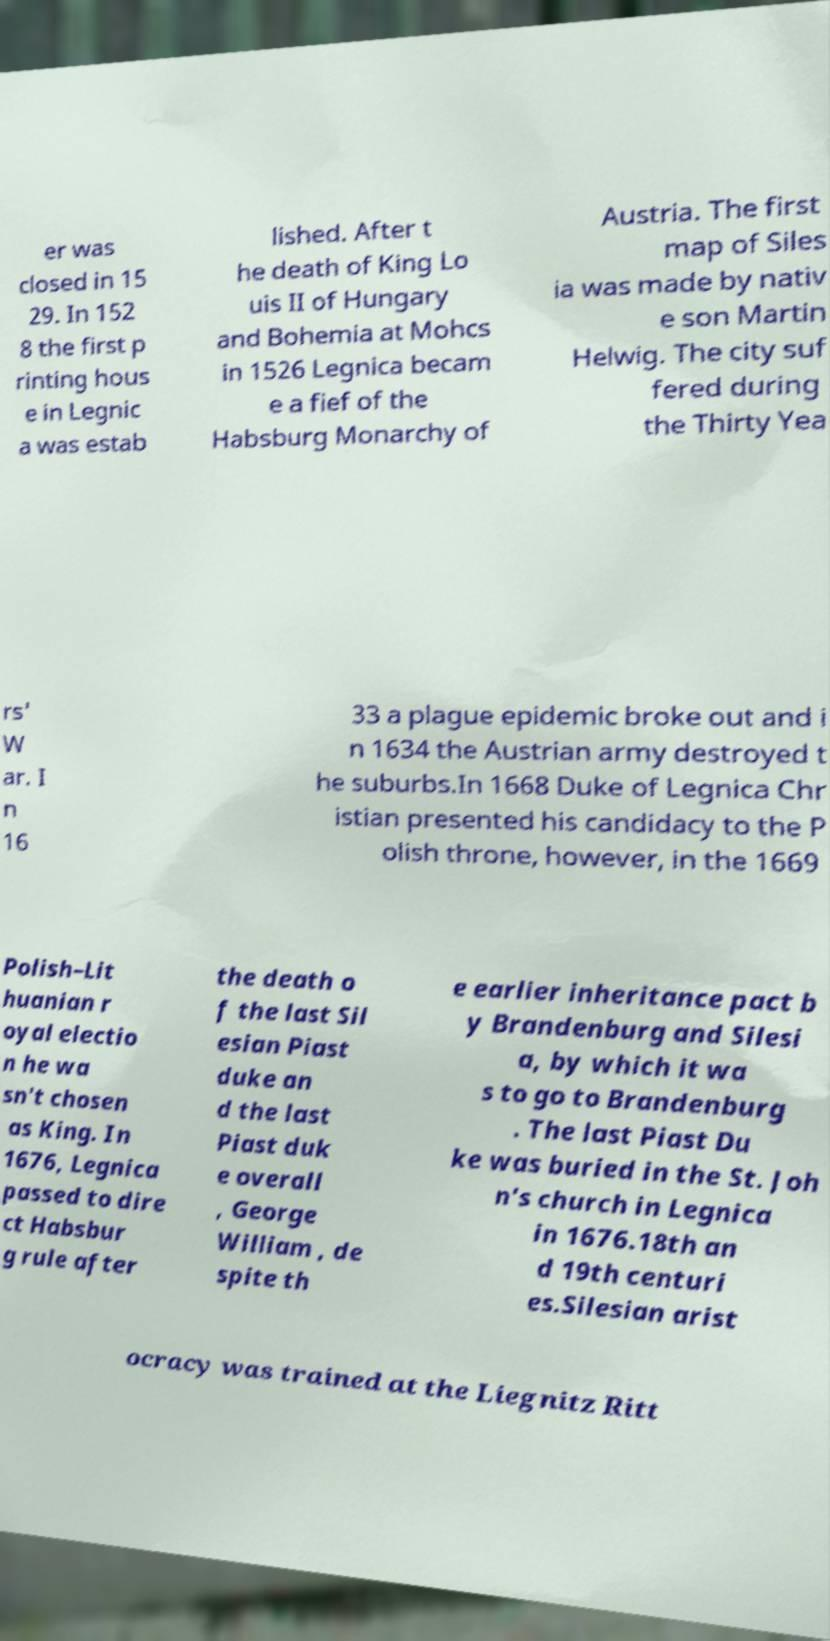Could you assist in decoding the text presented in this image and type it out clearly? er was closed in 15 29. In 152 8 the first p rinting hous e in Legnic a was estab lished. After t he death of King Lo uis II of Hungary and Bohemia at Mohcs in 1526 Legnica becam e a fief of the Habsburg Monarchy of Austria. The first map of Siles ia was made by nativ e son Martin Helwig. The city suf fered during the Thirty Yea rs' W ar. I n 16 33 a plague epidemic broke out and i n 1634 the Austrian army destroyed t he suburbs.In 1668 Duke of Legnica Chr istian presented his candidacy to the P olish throne, however, in the 1669 Polish–Lit huanian r oyal electio n he wa sn't chosen as King. In 1676, Legnica passed to dire ct Habsbur g rule after the death o f the last Sil esian Piast duke an d the last Piast duk e overall , George William , de spite th e earlier inheritance pact b y Brandenburg and Silesi a, by which it wa s to go to Brandenburg . The last Piast Du ke was buried in the St. Joh n's church in Legnica in 1676.18th an d 19th centuri es.Silesian arist ocracy was trained at the Liegnitz Ritt 